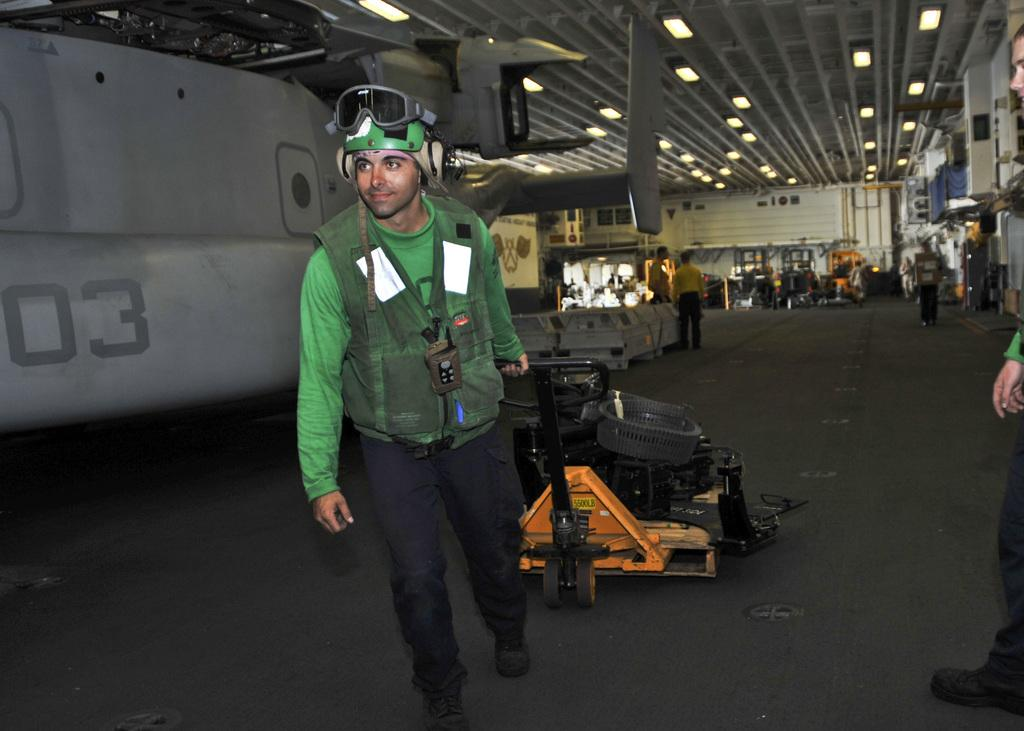What is the main subject of the image? There is a man standing in the center of the image. What is the man holding in the image? The man is holding a trolley. Can you describe the background of the image? There are people and some equipment visible in the background. What can be seen at the top of the image? There are lights at the top of the image. What type of meal is the man eating in the image? There is no meal present in the image; the man is holding a trolley. What kind of suit is the man wearing in the image? The man's clothing is not described in the image, so it cannot be determined if he is wearing a suit. 